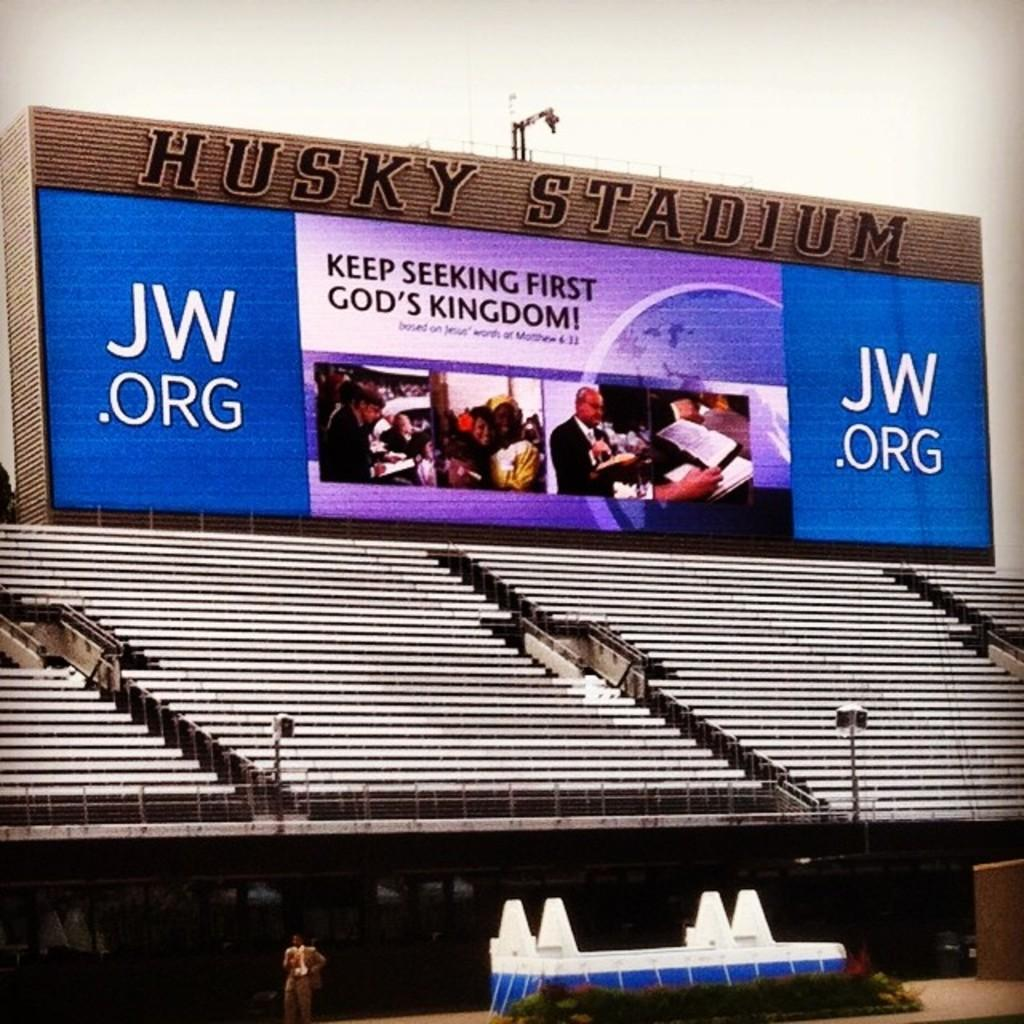<image>
Create a compact narrative representing the image presented. A sign hangs above stadium seating and says to keep seeking first God's kingdom. 